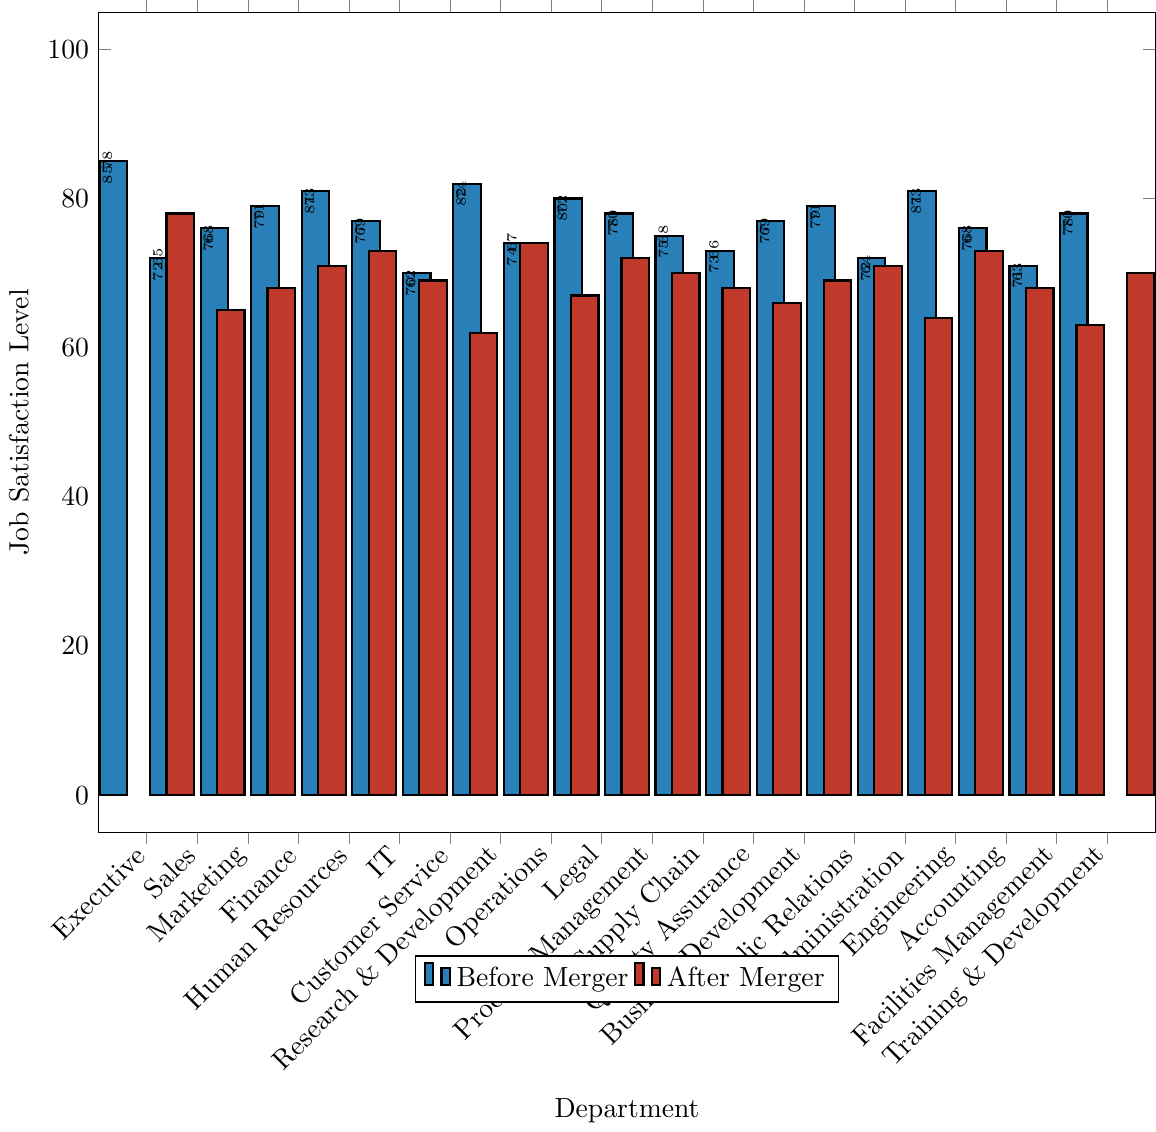Which department experienced the biggest drop in job satisfaction levels after the merger? The drop in job satisfaction is calculated by subtracting the "After Merger" values from the "Before Merger" values for each department. The largest drop is seen in the Customer Service department where the difference is 70 - 62 = 8.
Answer: Customer Service What was the average job satisfaction level across all departments before the merger? To find the average, sum all the "Before Merger" values and then divide by the number of departments. The sum is 1614 and there are 20 departments, so the average is 1614 / 20 = 80.7.
Answer: 80.7 How many departments had job satisfaction levels above 75 before the merger? Count the departments where the "Before Merger" values are greater than 75. These departments are Executive, Human Resources, Finance, Legal, Research & Development, Public Relations, Training & Development. There are 7 such departments.
Answer: 7 Which two departments have the same job satisfaction level after the merger? Identify departments with the same "After Merger" value. Finance and Public Relations both have a job satisfaction level of 71.
Answer: Finance and Public Relations Compare the job satisfaction levels before and after the merger for the IT department. How much did it change? The job satisfaction level for IT before the merger was 77 and after the merger was 69, so it changed by 77 - 69 = 8.
Answer: 8 Which department had the highest job satisfaction level before the merger and what was it? The department with the highest job satisfaction level before the merger can be found by looking at the "Before Merger" values. The Executive department had the highest level with 85.
Answer: Executive, 85 Did any department's job satisfaction level increase after the merger? Evaluate if any "After Merger" value is higher than the corresponding "Before Merger" value. All departments show a decrease in job satisfaction levels after the merger.
Answer: No What is the median job satisfaction level after the merger? List the "After Merger" values in ascending order: 62, 63, 64, 65, 66, 67, 68, 68, 69, 69, 70, 70, 71, 71, 72, 73, 73, 74, 78. With 20 values, the median is the average of the 10th and 11th values: (69 + 70) / 2 = 69.5.
Answer: 69.5 